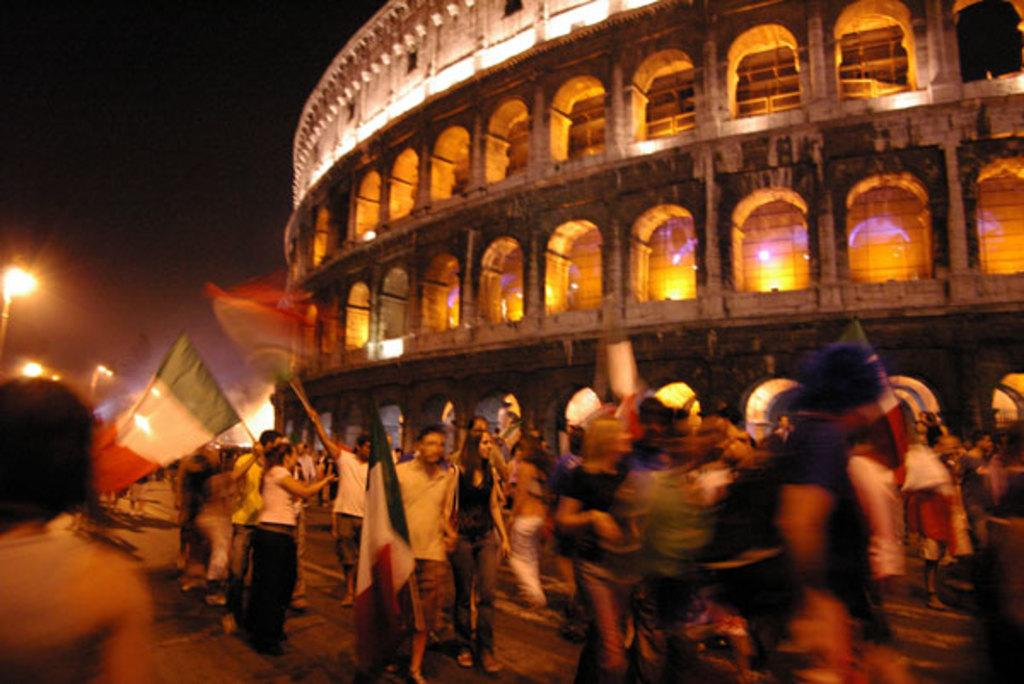What are the people in the image doing? The people in the image are standing and holding flags. What can be seen in the background of the image? There is a building in the image. Are there any additional features visible in the image? Yes, there are lights visible in the image. What type of swing can be seen in the image? There is no swing present in the image. How many people are in the crowd in the image? There is no crowd mentioned in the image; it features a group of people standing and holding flags. What song is being sung by the people in the image? There is no indication of any singing or song in the image. 